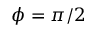<formula> <loc_0><loc_0><loc_500><loc_500>\phi = \pi / 2</formula> 